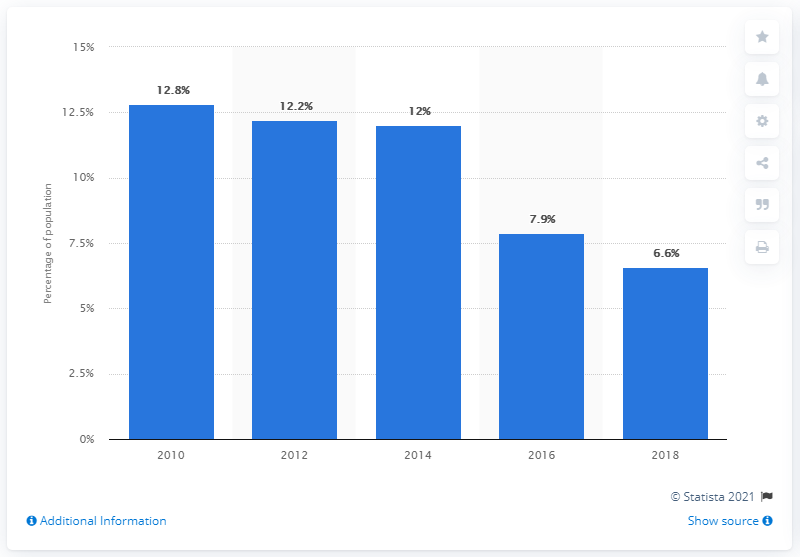Point out several critical features in this image. In 2018, approximately 6.6% of the Mexican population lived on less than $3.20 USD per day, according to recent data. 